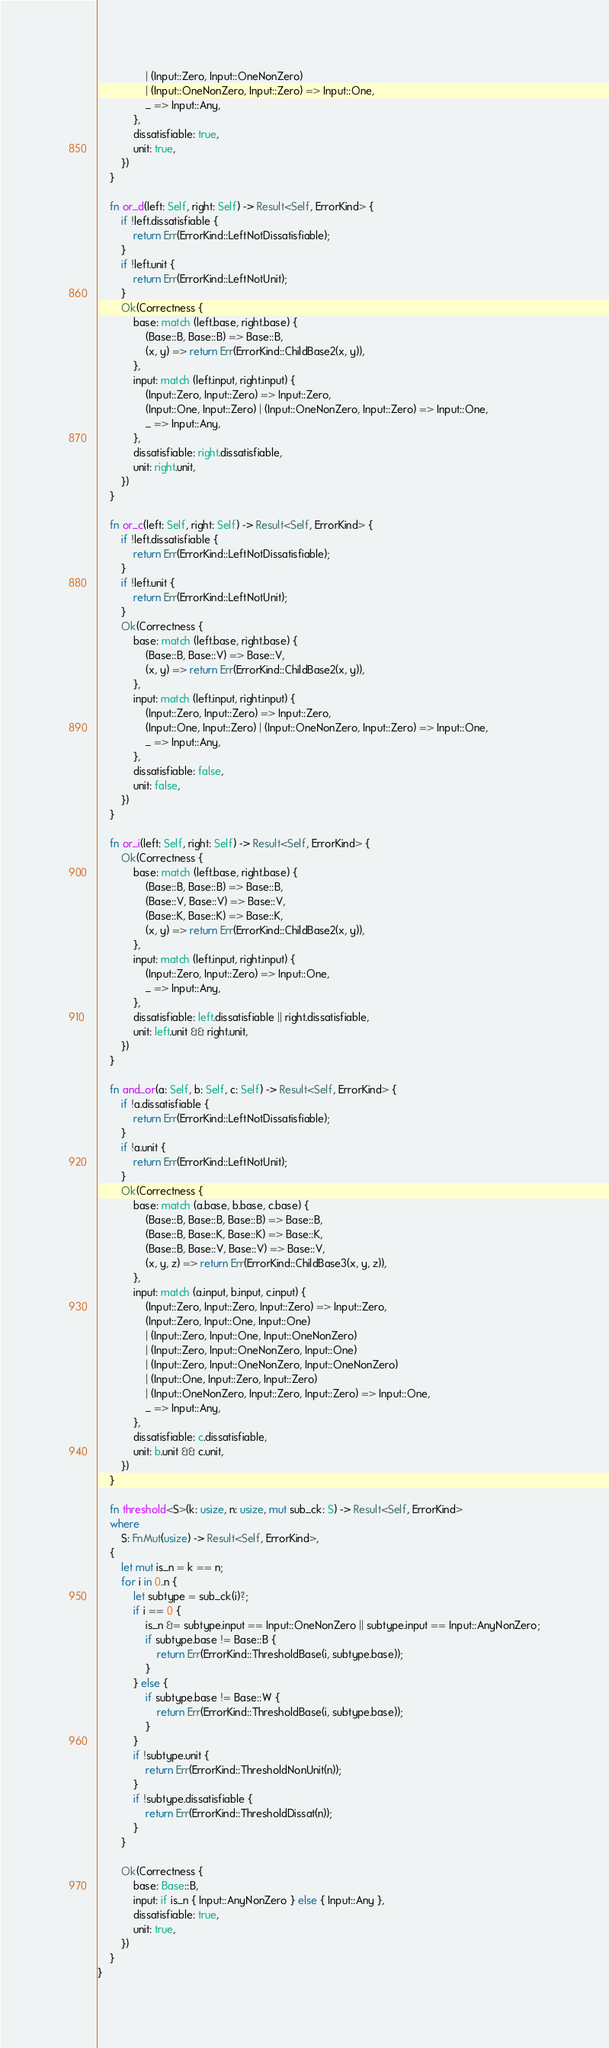<code> <loc_0><loc_0><loc_500><loc_500><_Rust_>                | (Input::Zero, Input::OneNonZero)
                | (Input::OneNonZero, Input::Zero) => Input::One,
                _ => Input::Any,
            },
            dissatisfiable: true,
            unit: true,
        })
    }

    fn or_d(left: Self, right: Self) -> Result<Self, ErrorKind> {
        if !left.dissatisfiable {
            return Err(ErrorKind::LeftNotDissatisfiable);
        }
        if !left.unit {
            return Err(ErrorKind::LeftNotUnit);
        }
        Ok(Correctness {
            base: match (left.base, right.base) {
                (Base::B, Base::B) => Base::B,
                (x, y) => return Err(ErrorKind::ChildBase2(x, y)),
            },
            input: match (left.input, right.input) {
                (Input::Zero, Input::Zero) => Input::Zero,
                (Input::One, Input::Zero) | (Input::OneNonZero, Input::Zero) => Input::One,
                _ => Input::Any,
            },
            dissatisfiable: right.dissatisfiable,
            unit: right.unit,
        })
    }

    fn or_c(left: Self, right: Self) -> Result<Self, ErrorKind> {
        if !left.dissatisfiable {
            return Err(ErrorKind::LeftNotDissatisfiable);
        }
        if !left.unit {
            return Err(ErrorKind::LeftNotUnit);
        }
        Ok(Correctness {
            base: match (left.base, right.base) {
                (Base::B, Base::V) => Base::V,
                (x, y) => return Err(ErrorKind::ChildBase2(x, y)),
            },
            input: match (left.input, right.input) {
                (Input::Zero, Input::Zero) => Input::Zero,
                (Input::One, Input::Zero) | (Input::OneNonZero, Input::Zero) => Input::One,
                _ => Input::Any,
            },
            dissatisfiable: false,
            unit: false,
        })
    }

    fn or_i(left: Self, right: Self) -> Result<Self, ErrorKind> {
        Ok(Correctness {
            base: match (left.base, right.base) {
                (Base::B, Base::B) => Base::B,
                (Base::V, Base::V) => Base::V,
                (Base::K, Base::K) => Base::K,
                (x, y) => return Err(ErrorKind::ChildBase2(x, y)),
            },
            input: match (left.input, right.input) {
                (Input::Zero, Input::Zero) => Input::One,
                _ => Input::Any,
            },
            dissatisfiable: left.dissatisfiable || right.dissatisfiable,
            unit: left.unit && right.unit,
        })
    }

    fn and_or(a: Self, b: Self, c: Self) -> Result<Self, ErrorKind> {
        if !a.dissatisfiable {
            return Err(ErrorKind::LeftNotDissatisfiable);
        }
        if !a.unit {
            return Err(ErrorKind::LeftNotUnit);
        }
        Ok(Correctness {
            base: match (a.base, b.base, c.base) {
                (Base::B, Base::B, Base::B) => Base::B,
                (Base::B, Base::K, Base::K) => Base::K,
                (Base::B, Base::V, Base::V) => Base::V,
                (x, y, z) => return Err(ErrorKind::ChildBase3(x, y, z)),
            },
            input: match (a.input, b.input, c.input) {
                (Input::Zero, Input::Zero, Input::Zero) => Input::Zero,
                (Input::Zero, Input::One, Input::One)
                | (Input::Zero, Input::One, Input::OneNonZero)
                | (Input::Zero, Input::OneNonZero, Input::One)
                | (Input::Zero, Input::OneNonZero, Input::OneNonZero)
                | (Input::One, Input::Zero, Input::Zero)
                | (Input::OneNonZero, Input::Zero, Input::Zero) => Input::One,
                _ => Input::Any,
            },
            dissatisfiable: c.dissatisfiable,
            unit: b.unit && c.unit,
        })
    }

    fn threshold<S>(k: usize, n: usize, mut sub_ck: S) -> Result<Self, ErrorKind>
    where
        S: FnMut(usize) -> Result<Self, ErrorKind>,
    {
        let mut is_n = k == n;
        for i in 0..n {
            let subtype = sub_ck(i)?;
            if i == 0 {
                is_n &= subtype.input == Input::OneNonZero || subtype.input == Input::AnyNonZero;
                if subtype.base != Base::B {
                    return Err(ErrorKind::ThresholdBase(i, subtype.base));
                }
            } else {
                if subtype.base != Base::W {
                    return Err(ErrorKind::ThresholdBase(i, subtype.base));
                }
            }
            if !subtype.unit {
                return Err(ErrorKind::ThresholdNonUnit(n));
            }
            if !subtype.dissatisfiable {
                return Err(ErrorKind::ThresholdDissat(n));
            }
        }

        Ok(Correctness {
            base: Base::B,
            input: if is_n { Input::AnyNonZero } else { Input::Any },
            dissatisfiable: true,
            unit: true,
        })
    }
}
</code> 